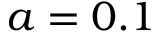<formula> <loc_0><loc_0><loc_500><loc_500>a = 0 . 1</formula> 